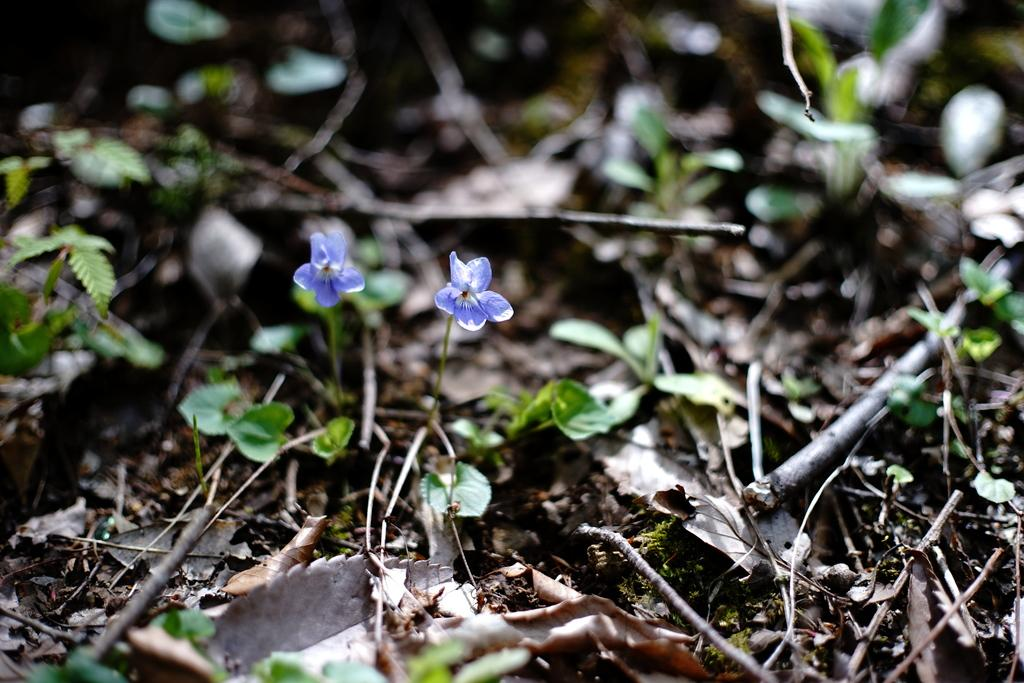What type of living organisms can be seen in the image? Plants and leaves are visible in the image. Can you describe the flowers in the image? There are two flowers in the middle of the image. What type of cast can be seen on the flowers in the image? There is no cast present on the flowers in the image. What type of grain is growing among the plants in the image? There is no grain visible in the image; it only features plants, leaves, and flowers. 